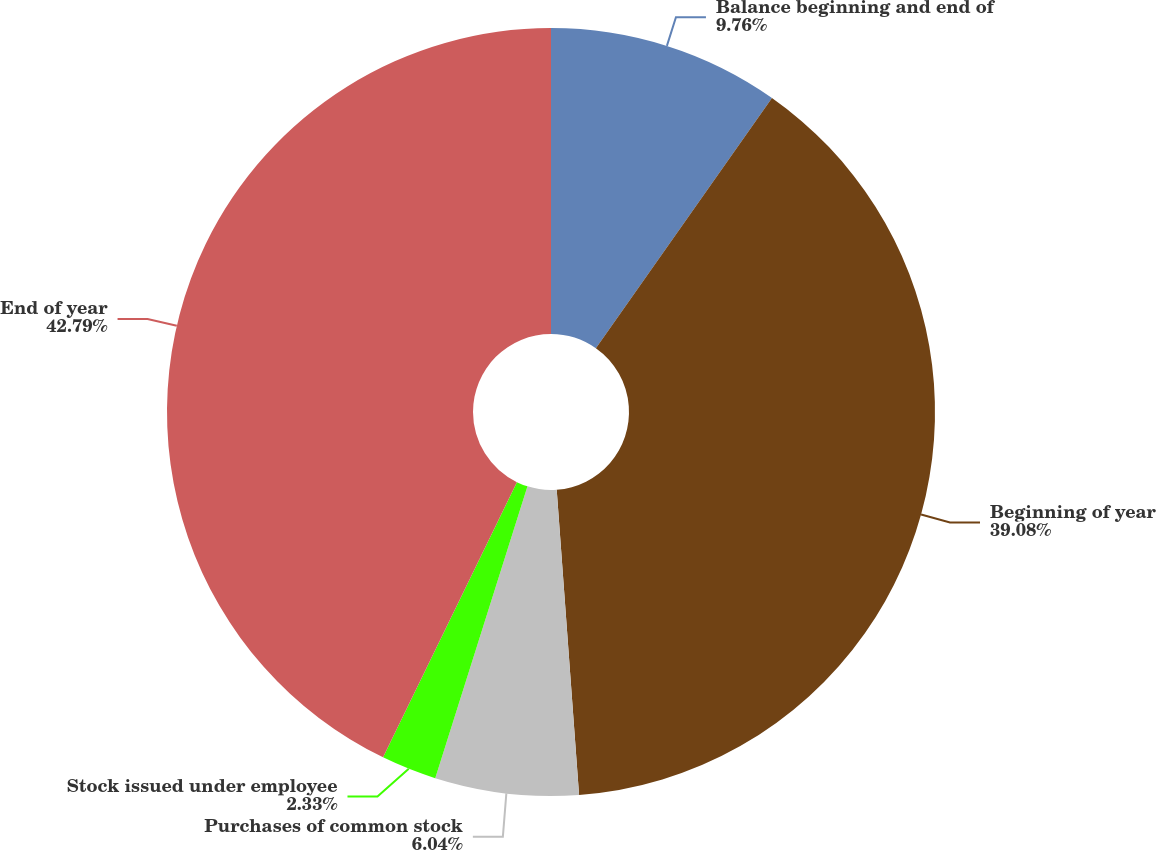Convert chart to OTSL. <chart><loc_0><loc_0><loc_500><loc_500><pie_chart><fcel>Balance beginning and end of<fcel>Beginning of year<fcel>Purchases of common stock<fcel>Stock issued under employee<fcel>End of year<nl><fcel>9.76%<fcel>39.08%<fcel>6.04%<fcel>2.33%<fcel>42.8%<nl></chart> 